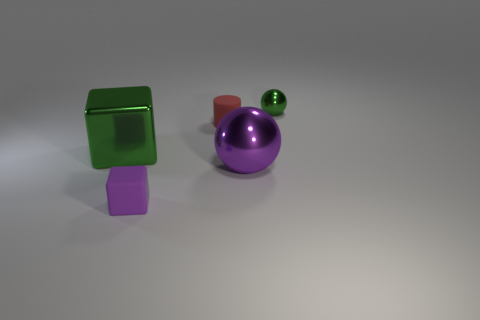Does the tiny cube have the same material as the tiny green object?
Offer a very short reply. No. How many small purple things are to the right of the green metallic object that is behind the metallic block?
Keep it short and to the point. 0. Is the cylinder the same size as the purple metal ball?
Keep it short and to the point. No. How many purple spheres are made of the same material as the green ball?
Provide a succinct answer. 1. The other thing that is the same shape as the small purple rubber thing is what size?
Make the answer very short. Large. There is a tiny matte thing that is to the right of the matte block; does it have the same shape as the big green object?
Keep it short and to the point. No. What shape is the small rubber object behind the ball in front of the cylinder?
Keep it short and to the point. Cylinder. Is there any other thing that is the same shape as the small red thing?
Provide a short and direct response. No. What is the color of the matte thing that is the same shape as the big green shiny object?
Give a very brief answer. Purple. There is a small sphere; does it have the same color as the cube that is on the left side of the tiny cube?
Offer a terse response. Yes. 